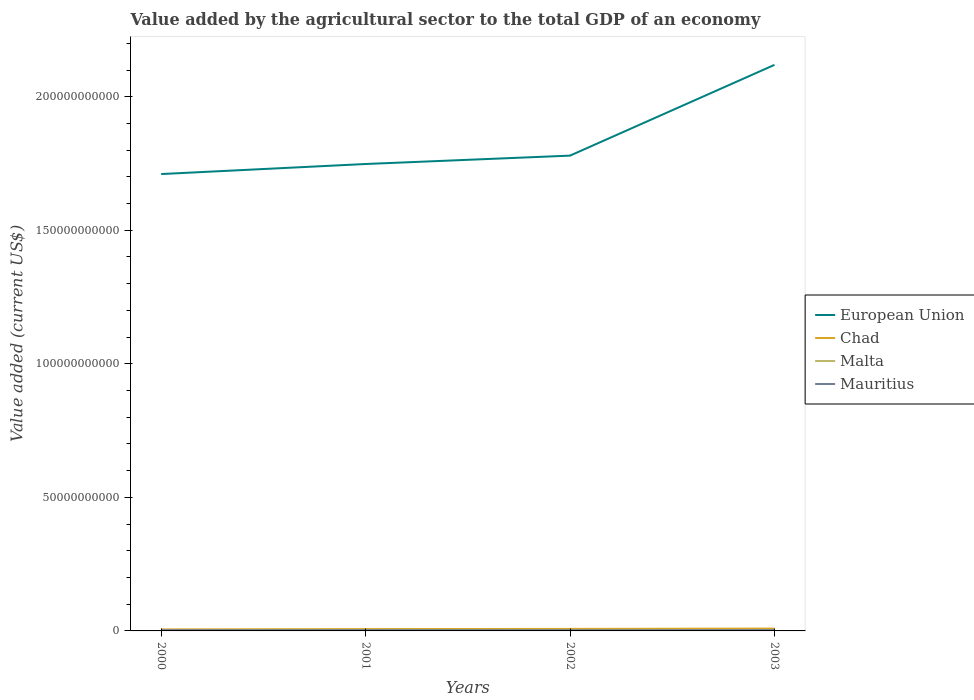Does the line corresponding to Chad intersect with the line corresponding to European Union?
Ensure brevity in your answer.  No. Is the number of lines equal to the number of legend labels?
Give a very brief answer. Yes. Across all years, what is the maximum value added by the agricultural sector to the total GDP in Chad?
Offer a very short reply. 5.64e+08. In which year was the value added by the agricultural sector to the total GDP in Mauritius maximum?
Provide a short and direct response. 2002. What is the total value added by the agricultural sector to the total GDP in Chad in the graph?
Ensure brevity in your answer.  -3.20e+08. What is the difference between the highest and the second highest value added by the agricultural sector to the total GDP in Mauritius?
Ensure brevity in your answer.  4.38e+07. What is the difference between the highest and the lowest value added by the agricultural sector to the total GDP in Mauritius?
Your answer should be very brief. 2. Is the value added by the agricultural sector to the total GDP in European Union strictly greater than the value added by the agricultural sector to the total GDP in Chad over the years?
Give a very brief answer. No. How many lines are there?
Keep it short and to the point. 4. How many years are there in the graph?
Provide a short and direct response. 4. Does the graph contain any zero values?
Keep it short and to the point. No. Does the graph contain grids?
Offer a terse response. No. Where does the legend appear in the graph?
Your answer should be very brief. Center right. What is the title of the graph?
Your answer should be very brief. Value added by the agricultural sector to the total GDP of an economy. What is the label or title of the Y-axis?
Give a very brief answer. Value added (current US$). What is the Value added (current US$) in European Union in 2000?
Give a very brief answer. 1.71e+11. What is the Value added (current US$) of Chad in 2000?
Your answer should be compact. 5.64e+08. What is the Value added (current US$) in Malta in 2000?
Provide a short and direct response. 8.10e+07. What is the Value added (current US$) of Mauritius in 2000?
Provide a succinct answer. 2.79e+08. What is the Value added (current US$) in European Union in 2001?
Your answer should be compact. 1.75e+11. What is the Value added (current US$) of Chad in 2001?
Your response must be concise. 6.89e+08. What is the Value added (current US$) of Malta in 2001?
Your answer should be compact. 9.39e+07. What is the Value added (current US$) in Mauritius in 2001?
Provide a short and direct response. 2.95e+08. What is the Value added (current US$) of European Union in 2002?
Give a very brief answer. 1.78e+11. What is the Value added (current US$) in Chad in 2002?
Your answer should be compact. 7.53e+08. What is the Value added (current US$) of Malta in 2002?
Ensure brevity in your answer.  1.03e+08. What is the Value added (current US$) of Mauritius in 2002?
Provide a short and direct response. 2.64e+08. What is the Value added (current US$) in European Union in 2003?
Your response must be concise. 2.12e+11. What is the Value added (current US$) of Chad in 2003?
Keep it short and to the point. 8.84e+08. What is the Value added (current US$) in Malta in 2003?
Your answer should be compact. 1.27e+08. What is the Value added (current US$) of Mauritius in 2003?
Your answer should be compact. 3.08e+08. Across all years, what is the maximum Value added (current US$) of European Union?
Your answer should be very brief. 2.12e+11. Across all years, what is the maximum Value added (current US$) of Chad?
Offer a terse response. 8.84e+08. Across all years, what is the maximum Value added (current US$) of Malta?
Your response must be concise. 1.27e+08. Across all years, what is the maximum Value added (current US$) in Mauritius?
Keep it short and to the point. 3.08e+08. Across all years, what is the minimum Value added (current US$) of European Union?
Provide a succinct answer. 1.71e+11. Across all years, what is the minimum Value added (current US$) in Chad?
Keep it short and to the point. 5.64e+08. Across all years, what is the minimum Value added (current US$) in Malta?
Provide a succinct answer. 8.10e+07. Across all years, what is the minimum Value added (current US$) in Mauritius?
Your answer should be compact. 2.64e+08. What is the total Value added (current US$) of European Union in the graph?
Give a very brief answer. 7.36e+11. What is the total Value added (current US$) of Chad in the graph?
Your answer should be very brief. 2.89e+09. What is the total Value added (current US$) of Malta in the graph?
Make the answer very short. 4.05e+08. What is the total Value added (current US$) in Mauritius in the graph?
Your response must be concise. 1.15e+09. What is the difference between the Value added (current US$) in European Union in 2000 and that in 2001?
Give a very brief answer. -3.76e+09. What is the difference between the Value added (current US$) in Chad in 2000 and that in 2001?
Keep it short and to the point. -1.25e+08. What is the difference between the Value added (current US$) in Malta in 2000 and that in 2001?
Ensure brevity in your answer.  -1.28e+07. What is the difference between the Value added (current US$) of Mauritius in 2000 and that in 2001?
Make the answer very short. -1.59e+07. What is the difference between the Value added (current US$) in European Union in 2000 and that in 2002?
Offer a terse response. -6.90e+09. What is the difference between the Value added (current US$) of Chad in 2000 and that in 2002?
Give a very brief answer. -1.90e+08. What is the difference between the Value added (current US$) of Malta in 2000 and that in 2002?
Your answer should be compact. -2.18e+07. What is the difference between the Value added (current US$) in Mauritius in 2000 and that in 2002?
Offer a terse response. 1.52e+07. What is the difference between the Value added (current US$) in European Union in 2000 and that in 2003?
Provide a succinct answer. -4.09e+1. What is the difference between the Value added (current US$) in Chad in 2000 and that in 2003?
Your answer should be very brief. -3.20e+08. What is the difference between the Value added (current US$) of Malta in 2000 and that in 2003?
Keep it short and to the point. -4.63e+07. What is the difference between the Value added (current US$) of Mauritius in 2000 and that in 2003?
Give a very brief answer. -2.86e+07. What is the difference between the Value added (current US$) in European Union in 2001 and that in 2002?
Your answer should be very brief. -3.14e+09. What is the difference between the Value added (current US$) of Chad in 2001 and that in 2002?
Offer a very short reply. -6.46e+07. What is the difference between the Value added (current US$) of Malta in 2001 and that in 2002?
Your answer should be compact. -9.00e+06. What is the difference between the Value added (current US$) in Mauritius in 2001 and that in 2002?
Provide a succinct answer. 3.11e+07. What is the difference between the Value added (current US$) in European Union in 2001 and that in 2003?
Offer a terse response. -3.71e+1. What is the difference between the Value added (current US$) of Chad in 2001 and that in 2003?
Offer a terse response. -1.95e+08. What is the difference between the Value added (current US$) of Malta in 2001 and that in 2003?
Offer a very short reply. -3.35e+07. What is the difference between the Value added (current US$) in Mauritius in 2001 and that in 2003?
Your answer should be very brief. -1.27e+07. What is the difference between the Value added (current US$) of European Union in 2002 and that in 2003?
Offer a terse response. -3.40e+1. What is the difference between the Value added (current US$) in Chad in 2002 and that in 2003?
Your response must be concise. -1.30e+08. What is the difference between the Value added (current US$) of Malta in 2002 and that in 2003?
Offer a terse response. -2.45e+07. What is the difference between the Value added (current US$) of Mauritius in 2002 and that in 2003?
Offer a very short reply. -4.38e+07. What is the difference between the Value added (current US$) of European Union in 2000 and the Value added (current US$) of Chad in 2001?
Make the answer very short. 1.70e+11. What is the difference between the Value added (current US$) of European Union in 2000 and the Value added (current US$) of Malta in 2001?
Offer a terse response. 1.71e+11. What is the difference between the Value added (current US$) in European Union in 2000 and the Value added (current US$) in Mauritius in 2001?
Offer a terse response. 1.71e+11. What is the difference between the Value added (current US$) in Chad in 2000 and the Value added (current US$) in Malta in 2001?
Make the answer very short. 4.70e+08. What is the difference between the Value added (current US$) in Chad in 2000 and the Value added (current US$) in Mauritius in 2001?
Make the answer very short. 2.69e+08. What is the difference between the Value added (current US$) of Malta in 2000 and the Value added (current US$) of Mauritius in 2001?
Your answer should be compact. -2.14e+08. What is the difference between the Value added (current US$) of European Union in 2000 and the Value added (current US$) of Chad in 2002?
Your answer should be compact. 1.70e+11. What is the difference between the Value added (current US$) of European Union in 2000 and the Value added (current US$) of Malta in 2002?
Make the answer very short. 1.71e+11. What is the difference between the Value added (current US$) in European Union in 2000 and the Value added (current US$) in Mauritius in 2002?
Your answer should be very brief. 1.71e+11. What is the difference between the Value added (current US$) of Chad in 2000 and the Value added (current US$) of Malta in 2002?
Make the answer very short. 4.61e+08. What is the difference between the Value added (current US$) in Chad in 2000 and the Value added (current US$) in Mauritius in 2002?
Provide a succinct answer. 3.00e+08. What is the difference between the Value added (current US$) in Malta in 2000 and the Value added (current US$) in Mauritius in 2002?
Offer a very short reply. -1.83e+08. What is the difference between the Value added (current US$) of European Union in 2000 and the Value added (current US$) of Chad in 2003?
Provide a succinct answer. 1.70e+11. What is the difference between the Value added (current US$) in European Union in 2000 and the Value added (current US$) in Malta in 2003?
Keep it short and to the point. 1.71e+11. What is the difference between the Value added (current US$) of European Union in 2000 and the Value added (current US$) of Mauritius in 2003?
Provide a succinct answer. 1.71e+11. What is the difference between the Value added (current US$) of Chad in 2000 and the Value added (current US$) of Malta in 2003?
Offer a terse response. 4.36e+08. What is the difference between the Value added (current US$) of Chad in 2000 and the Value added (current US$) of Mauritius in 2003?
Offer a terse response. 2.56e+08. What is the difference between the Value added (current US$) in Malta in 2000 and the Value added (current US$) in Mauritius in 2003?
Your answer should be compact. -2.27e+08. What is the difference between the Value added (current US$) of European Union in 2001 and the Value added (current US$) of Chad in 2002?
Keep it short and to the point. 1.74e+11. What is the difference between the Value added (current US$) in European Union in 2001 and the Value added (current US$) in Malta in 2002?
Your response must be concise. 1.75e+11. What is the difference between the Value added (current US$) of European Union in 2001 and the Value added (current US$) of Mauritius in 2002?
Keep it short and to the point. 1.75e+11. What is the difference between the Value added (current US$) of Chad in 2001 and the Value added (current US$) of Malta in 2002?
Offer a very short reply. 5.86e+08. What is the difference between the Value added (current US$) of Chad in 2001 and the Value added (current US$) of Mauritius in 2002?
Your response must be concise. 4.25e+08. What is the difference between the Value added (current US$) of Malta in 2001 and the Value added (current US$) of Mauritius in 2002?
Ensure brevity in your answer.  -1.70e+08. What is the difference between the Value added (current US$) of European Union in 2001 and the Value added (current US$) of Chad in 2003?
Offer a very short reply. 1.74e+11. What is the difference between the Value added (current US$) of European Union in 2001 and the Value added (current US$) of Malta in 2003?
Your answer should be very brief. 1.75e+11. What is the difference between the Value added (current US$) of European Union in 2001 and the Value added (current US$) of Mauritius in 2003?
Your answer should be very brief. 1.75e+11. What is the difference between the Value added (current US$) of Chad in 2001 and the Value added (current US$) of Malta in 2003?
Your answer should be very brief. 5.61e+08. What is the difference between the Value added (current US$) of Chad in 2001 and the Value added (current US$) of Mauritius in 2003?
Ensure brevity in your answer.  3.81e+08. What is the difference between the Value added (current US$) of Malta in 2001 and the Value added (current US$) of Mauritius in 2003?
Make the answer very short. -2.14e+08. What is the difference between the Value added (current US$) in European Union in 2002 and the Value added (current US$) in Chad in 2003?
Your answer should be compact. 1.77e+11. What is the difference between the Value added (current US$) of European Union in 2002 and the Value added (current US$) of Malta in 2003?
Ensure brevity in your answer.  1.78e+11. What is the difference between the Value added (current US$) of European Union in 2002 and the Value added (current US$) of Mauritius in 2003?
Offer a terse response. 1.78e+11. What is the difference between the Value added (current US$) in Chad in 2002 and the Value added (current US$) in Malta in 2003?
Keep it short and to the point. 6.26e+08. What is the difference between the Value added (current US$) of Chad in 2002 and the Value added (current US$) of Mauritius in 2003?
Provide a succinct answer. 4.46e+08. What is the difference between the Value added (current US$) of Malta in 2002 and the Value added (current US$) of Mauritius in 2003?
Ensure brevity in your answer.  -2.05e+08. What is the average Value added (current US$) of European Union per year?
Provide a short and direct response. 1.84e+11. What is the average Value added (current US$) in Chad per year?
Make the answer very short. 7.22e+08. What is the average Value added (current US$) of Malta per year?
Your answer should be compact. 1.01e+08. What is the average Value added (current US$) of Mauritius per year?
Keep it short and to the point. 2.87e+08. In the year 2000, what is the difference between the Value added (current US$) of European Union and Value added (current US$) of Chad?
Offer a terse response. 1.70e+11. In the year 2000, what is the difference between the Value added (current US$) of European Union and Value added (current US$) of Malta?
Your answer should be very brief. 1.71e+11. In the year 2000, what is the difference between the Value added (current US$) in European Union and Value added (current US$) in Mauritius?
Your answer should be compact. 1.71e+11. In the year 2000, what is the difference between the Value added (current US$) of Chad and Value added (current US$) of Malta?
Your answer should be very brief. 4.83e+08. In the year 2000, what is the difference between the Value added (current US$) of Chad and Value added (current US$) of Mauritius?
Give a very brief answer. 2.85e+08. In the year 2000, what is the difference between the Value added (current US$) in Malta and Value added (current US$) in Mauritius?
Offer a terse response. -1.98e+08. In the year 2001, what is the difference between the Value added (current US$) in European Union and Value added (current US$) in Chad?
Provide a short and direct response. 1.74e+11. In the year 2001, what is the difference between the Value added (current US$) in European Union and Value added (current US$) in Malta?
Your answer should be very brief. 1.75e+11. In the year 2001, what is the difference between the Value added (current US$) in European Union and Value added (current US$) in Mauritius?
Your response must be concise. 1.75e+11. In the year 2001, what is the difference between the Value added (current US$) in Chad and Value added (current US$) in Malta?
Keep it short and to the point. 5.95e+08. In the year 2001, what is the difference between the Value added (current US$) of Chad and Value added (current US$) of Mauritius?
Your response must be concise. 3.94e+08. In the year 2001, what is the difference between the Value added (current US$) of Malta and Value added (current US$) of Mauritius?
Provide a succinct answer. -2.01e+08. In the year 2002, what is the difference between the Value added (current US$) of European Union and Value added (current US$) of Chad?
Ensure brevity in your answer.  1.77e+11. In the year 2002, what is the difference between the Value added (current US$) of European Union and Value added (current US$) of Malta?
Give a very brief answer. 1.78e+11. In the year 2002, what is the difference between the Value added (current US$) of European Union and Value added (current US$) of Mauritius?
Your answer should be compact. 1.78e+11. In the year 2002, what is the difference between the Value added (current US$) of Chad and Value added (current US$) of Malta?
Your answer should be very brief. 6.51e+08. In the year 2002, what is the difference between the Value added (current US$) in Chad and Value added (current US$) in Mauritius?
Your answer should be very brief. 4.89e+08. In the year 2002, what is the difference between the Value added (current US$) in Malta and Value added (current US$) in Mauritius?
Offer a terse response. -1.61e+08. In the year 2003, what is the difference between the Value added (current US$) in European Union and Value added (current US$) in Chad?
Ensure brevity in your answer.  2.11e+11. In the year 2003, what is the difference between the Value added (current US$) of European Union and Value added (current US$) of Malta?
Your response must be concise. 2.12e+11. In the year 2003, what is the difference between the Value added (current US$) of European Union and Value added (current US$) of Mauritius?
Ensure brevity in your answer.  2.12e+11. In the year 2003, what is the difference between the Value added (current US$) in Chad and Value added (current US$) in Malta?
Provide a succinct answer. 7.56e+08. In the year 2003, what is the difference between the Value added (current US$) of Chad and Value added (current US$) of Mauritius?
Your response must be concise. 5.76e+08. In the year 2003, what is the difference between the Value added (current US$) in Malta and Value added (current US$) in Mauritius?
Your answer should be compact. -1.80e+08. What is the ratio of the Value added (current US$) of European Union in 2000 to that in 2001?
Your answer should be compact. 0.98. What is the ratio of the Value added (current US$) in Chad in 2000 to that in 2001?
Provide a short and direct response. 0.82. What is the ratio of the Value added (current US$) of Malta in 2000 to that in 2001?
Make the answer very short. 0.86. What is the ratio of the Value added (current US$) of Mauritius in 2000 to that in 2001?
Your answer should be very brief. 0.95. What is the ratio of the Value added (current US$) in European Union in 2000 to that in 2002?
Offer a very short reply. 0.96. What is the ratio of the Value added (current US$) of Chad in 2000 to that in 2002?
Keep it short and to the point. 0.75. What is the ratio of the Value added (current US$) in Malta in 2000 to that in 2002?
Keep it short and to the point. 0.79. What is the ratio of the Value added (current US$) of Mauritius in 2000 to that in 2002?
Offer a very short reply. 1.06. What is the ratio of the Value added (current US$) of European Union in 2000 to that in 2003?
Give a very brief answer. 0.81. What is the ratio of the Value added (current US$) of Chad in 2000 to that in 2003?
Provide a succinct answer. 0.64. What is the ratio of the Value added (current US$) in Malta in 2000 to that in 2003?
Offer a very short reply. 0.64. What is the ratio of the Value added (current US$) in Mauritius in 2000 to that in 2003?
Offer a terse response. 0.91. What is the ratio of the Value added (current US$) in European Union in 2001 to that in 2002?
Ensure brevity in your answer.  0.98. What is the ratio of the Value added (current US$) of Chad in 2001 to that in 2002?
Provide a succinct answer. 0.91. What is the ratio of the Value added (current US$) of Malta in 2001 to that in 2002?
Keep it short and to the point. 0.91. What is the ratio of the Value added (current US$) of Mauritius in 2001 to that in 2002?
Offer a very short reply. 1.12. What is the ratio of the Value added (current US$) in European Union in 2001 to that in 2003?
Your response must be concise. 0.82. What is the ratio of the Value added (current US$) in Chad in 2001 to that in 2003?
Give a very brief answer. 0.78. What is the ratio of the Value added (current US$) of Malta in 2001 to that in 2003?
Provide a short and direct response. 0.74. What is the ratio of the Value added (current US$) in Mauritius in 2001 to that in 2003?
Provide a succinct answer. 0.96. What is the ratio of the Value added (current US$) in European Union in 2002 to that in 2003?
Offer a terse response. 0.84. What is the ratio of the Value added (current US$) in Chad in 2002 to that in 2003?
Give a very brief answer. 0.85. What is the ratio of the Value added (current US$) in Malta in 2002 to that in 2003?
Offer a terse response. 0.81. What is the ratio of the Value added (current US$) of Mauritius in 2002 to that in 2003?
Provide a short and direct response. 0.86. What is the difference between the highest and the second highest Value added (current US$) of European Union?
Offer a terse response. 3.40e+1. What is the difference between the highest and the second highest Value added (current US$) of Chad?
Provide a short and direct response. 1.30e+08. What is the difference between the highest and the second highest Value added (current US$) of Malta?
Provide a succinct answer. 2.45e+07. What is the difference between the highest and the second highest Value added (current US$) of Mauritius?
Give a very brief answer. 1.27e+07. What is the difference between the highest and the lowest Value added (current US$) of European Union?
Keep it short and to the point. 4.09e+1. What is the difference between the highest and the lowest Value added (current US$) in Chad?
Your response must be concise. 3.20e+08. What is the difference between the highest and the lowest Value added (current US$) of Malta?
Give a very brief answer. 4.63e+07. What is the difference between the highest and the lowest Value added (current US$) in Mauritius?
Offer a very short reply. 4.38e+07. 